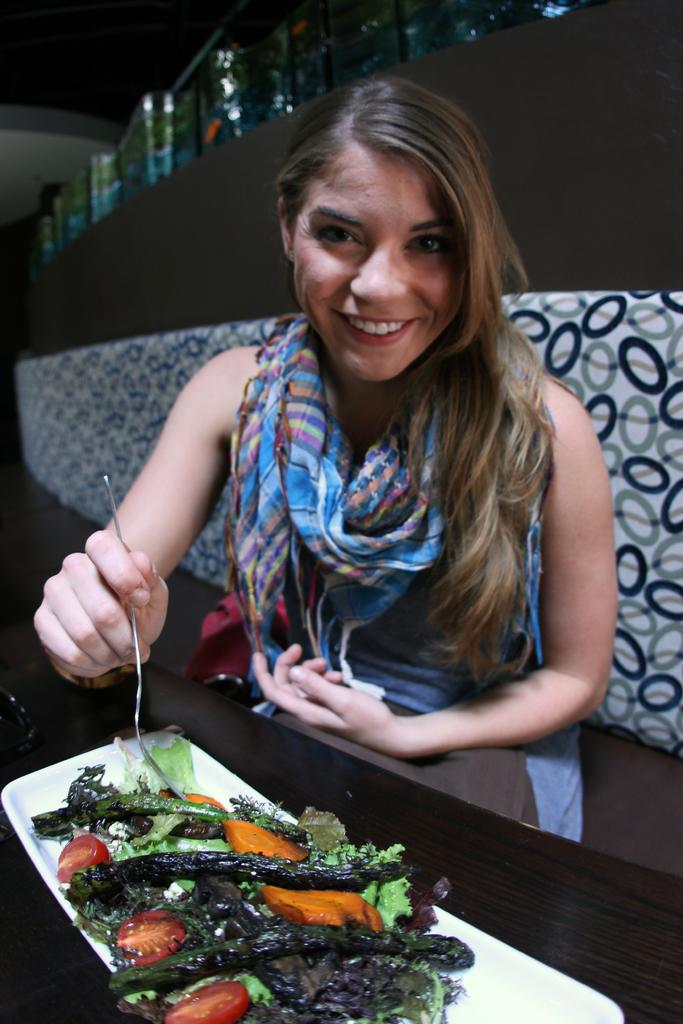What is the person in the image doing? The person is sitting in the image. What is the person holding in the image? The person is holding a spoon. What can be seen around the person's neck in the image? The person is wearing a blue color scarf. What is on the table in front of the person? There is food in a plate in front of the person. What color is the plate? The plate is white in color. What type of umbrella is the person using to shield themselves from the sun in the image? There is no umbrella present in the image; the person is sitting indoors. What kind of pickle is the person eating with the spoon in the image? There is no pickle visible in the image; the person is holding a spoon, but the food on the plate is not specified. 